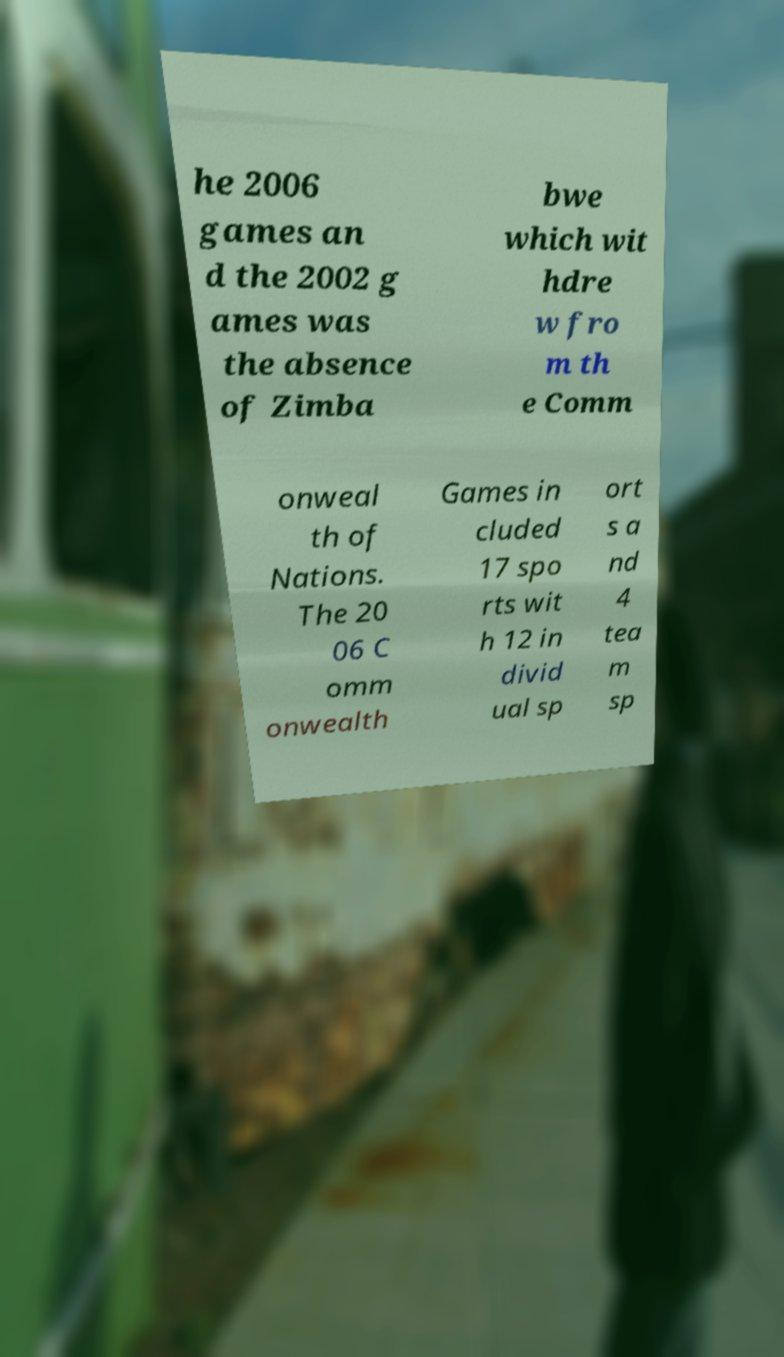There's text embedded in this image that I need extracted. Can you transcribe it verbatim? he 2006 games an d the 2002 g ames was the absence of Zimba bwe which wit hdre w fro m th e Comm onweal th of Nations. The 20 06 C omm onwealth Games in cluded 17 spo rts wit h 12 in divid ual sp ort s a nd 4 tea m sp 